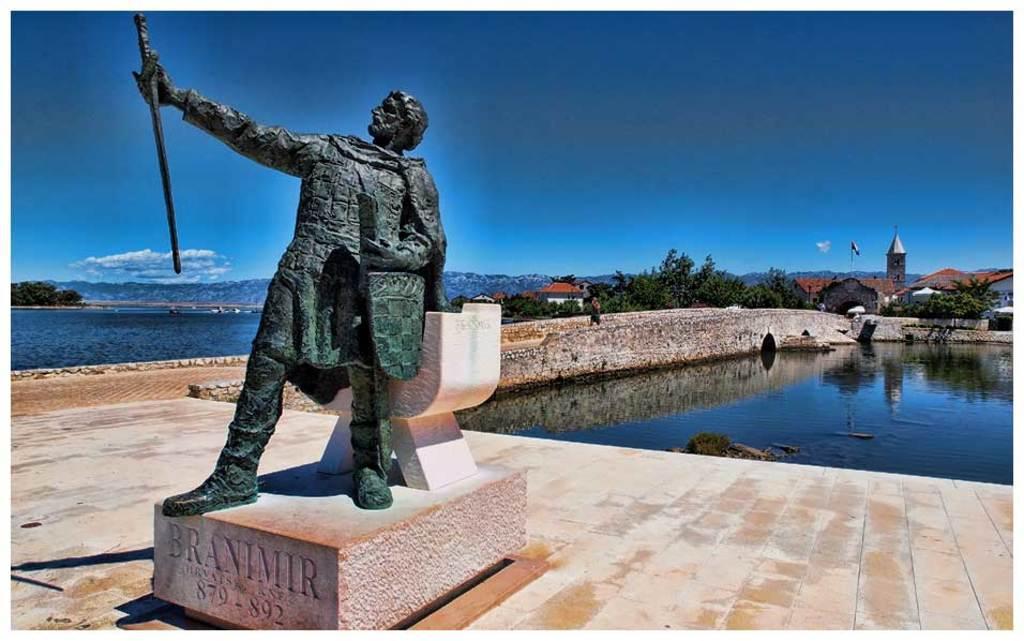How would you summarize this image in a sentence or two? In this image we can see a statue on a stand with some text on it. We can also see a water body, a person on the pathway, some trees, some houses with roof, the hills and the sky which looks cloudy. 